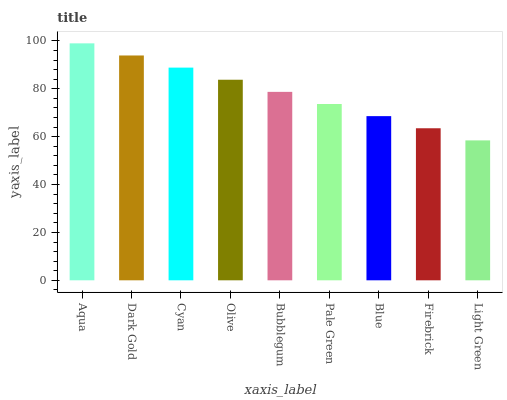Is Light Green the minimum?
Answer yes or no. Yes. Is Aqua the maximum?
Answer yes or no. Yes. Is Dark Gold the minimum?
Answer yes or no. No. Is Dark Gold the maximum?
Answer yes or no. No. Is Aqua greater than Dark Gold?
Answer yes or no. Yes. Is Dark Gold less than Aqua?
Answer yes or no. Yes. Is Dark Gold greater than Aqua?
Answer yes or no. No. Is Aqua less than Dark Gold?
Answer yes or no. No. Is Bubblegum the high median?
Answer yes or no. Yes. Is Bubblegum the low median?
Answer yes or no. Yes. Is Dark Gold the high median?
Answer yes or no. No. Is Cyan the low median?
Answer yes or no. No. 